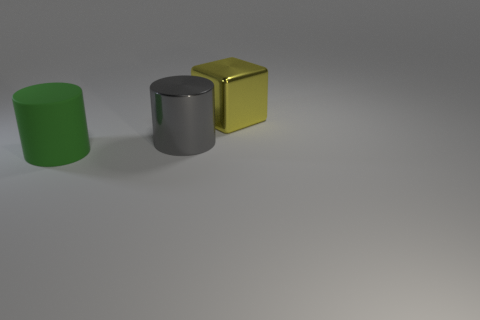Subtract 1 cubes. How many cubes are left? 0 Add 1 tiny green balls. How many tiny green balls exist? 1 Add 3 big brown cylinders. How many objects exist? 6 Subtract 0 cyan balls. How many objects are left? 3 Subtract all cylinders. How many objects are left? 1 Subtract all cyan cylinders. Subtract all blue cubes. How many cylinders are left? 2 Subtract all cyan cylinders. How many brown cubes are left? 0 Subtract all gray things. Subtract all cylinders. How many objects are left? 0 Add 2 yellow blocks. How many yellow blocks are left? 3 